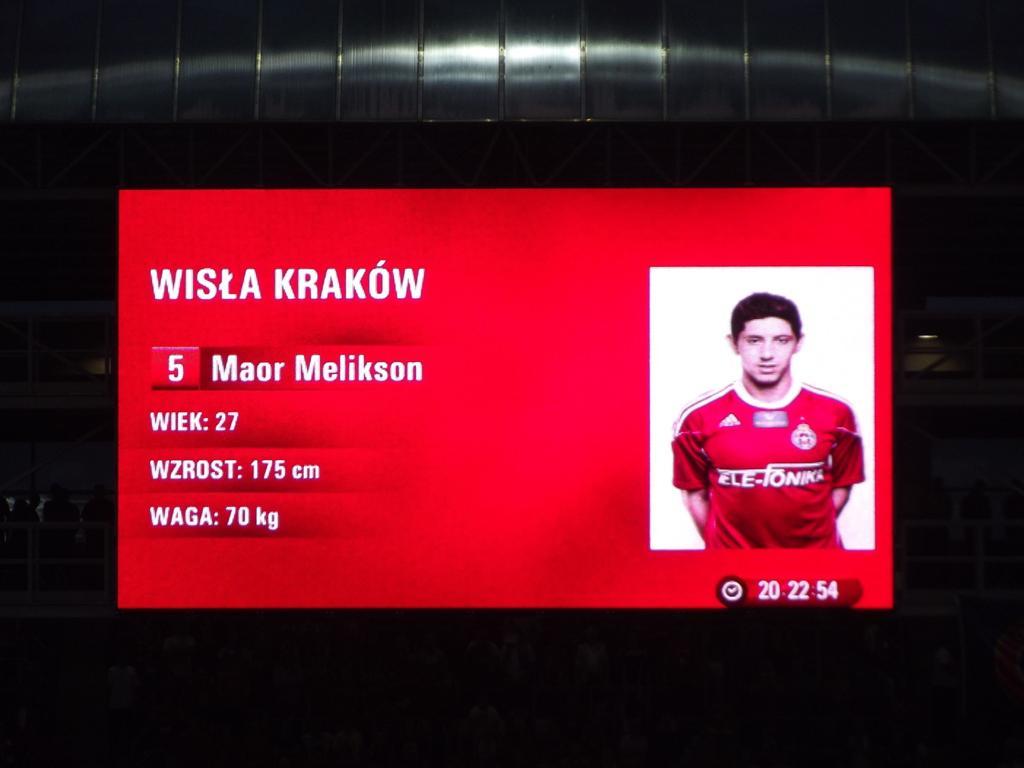What is the players number?
Give a very brief answer. 5. 